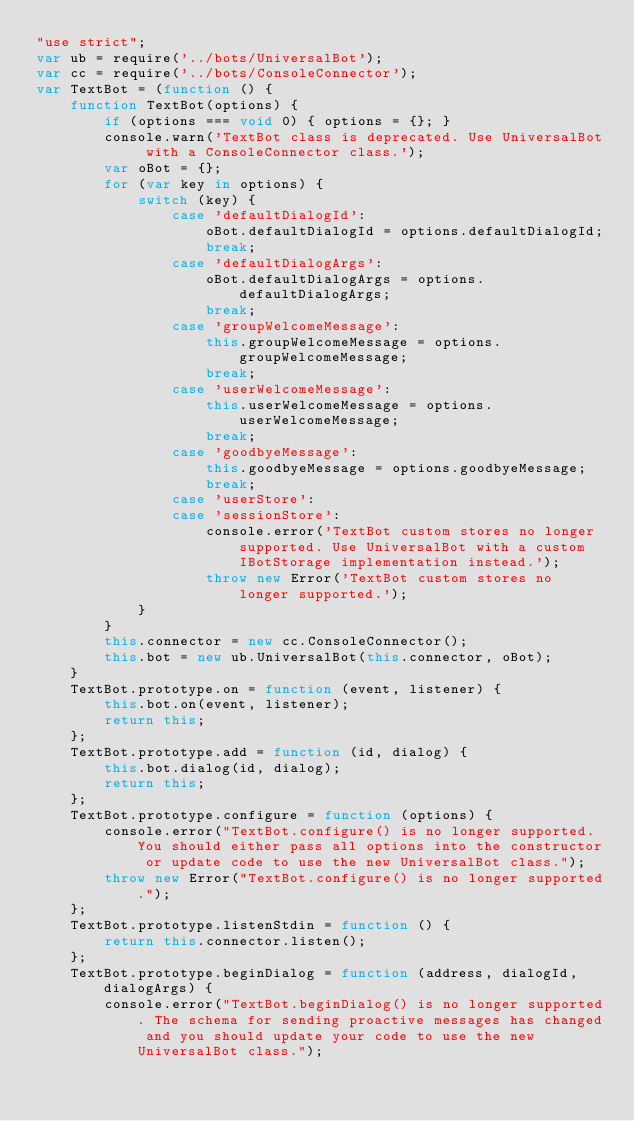Convert code to text. <code><loc_0><loc_0><loc_500><loc_500><_JavaScript_>"use strict";
var ub = require('../bots/UniversalBot');
var cc = require('../bots/ConsoleConnector');
var TextBot = (function () {
    function TextBot(options) {
        if (options === void 0) { options = {}; }
        console.warn('TextBot class is deprecated. Use UniversalBot with a ConsoleConnector class.');
        var oBot = {};
        for (var key in options) {
            switch (key) {
                case 'defaultDialogId':
                    oBot.defaultDialogId = options.defaultDialogId;
                    break;
                case 'defaultDialogArgs':
                    oBot.defaultDialogArgs = options.defaultDialogArgs;
                    break;
                case 'groupWelcomeMessage':
                    this.groupWelcomeMessage = options.groupWelcomeMessage;
                    break;
                case 'userWelcomeMessage':
                    this.userWelcomeMessage = options.userWelcomeMessage;
                    break;
                case 'goodbyeMessage':
                    this.goodbyeMessage = options.goodbyeMessage;
                    break;
                case 'userStore':
                case 'sessionStore':
                    console.error('TextBot custom stores no longer supported. Use UniversalBot with a custom IBotStorage implementation instead.');
                    throw new Error('TextBot custom stores no longer supported.');
            }
        }
        this.connector = new cc.ConsoleConnector();
        this.bot = new ub.UniversalBot(this.connector, oBot);
    }
    TextBot.prototype.on = function (event, listener) {
        this.bot.on(event, listener);
        return this;
    };
    TextBot.prototype.add = function (id, dialog) {
        this.bot.dialog(id, dialog);
        return this;
    };
    TextBot.prototype.configure = function (options) {
        console.error("TextBot.configure() is no longer supported. You should either pass all options into the constructor or update code to use the new UniversalBot class.");
        throw new Error("TextBot.configure() is no longer supported.");
    };
    TextBot.prototype.listenStdin = function () {
        return this.connector.listen();
    };
    TextBot.prototype.beginDialog = function (address, dialogId, dialogArgs) {
        console.error("TextBot.beginDialog() is no longer supported. The schema for sending proactive messages has changed and you should update your code to use the new UniversalBot class.");</code> 